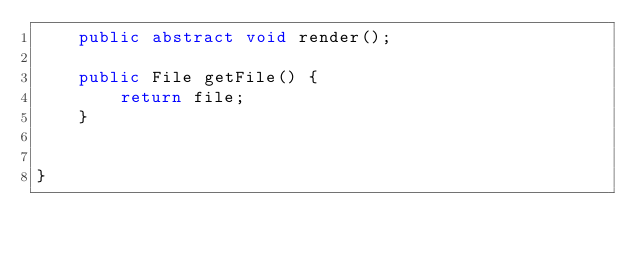Convert code to text. <code><loc_0><loc_0><loc_500><loc_500><_Java_>	public abstract void render();

	public File getFile() {
		return file;
	}


}
</code> 